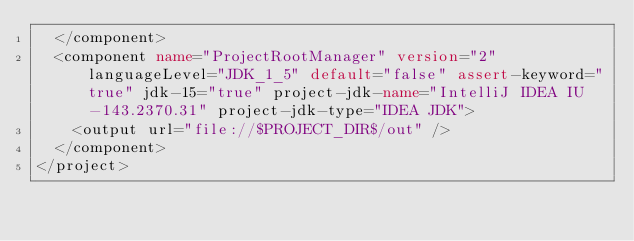Convert code to text. <code><loc_0><loc_0><loc_500><loc_500><_XML_>  </component>
  <component name="ProjectRootManager" version="2" languageLevel="JDK_1_5" default="false" assert-keyword="true" jdk-15="true" project-jdk-name="IntelliJ IDEA IU-143.2370.31" project-jdk-type="IDEA JDK">
    <output url="file://$PROJECT_DIR$/out" />
  </component>
</project></code> 